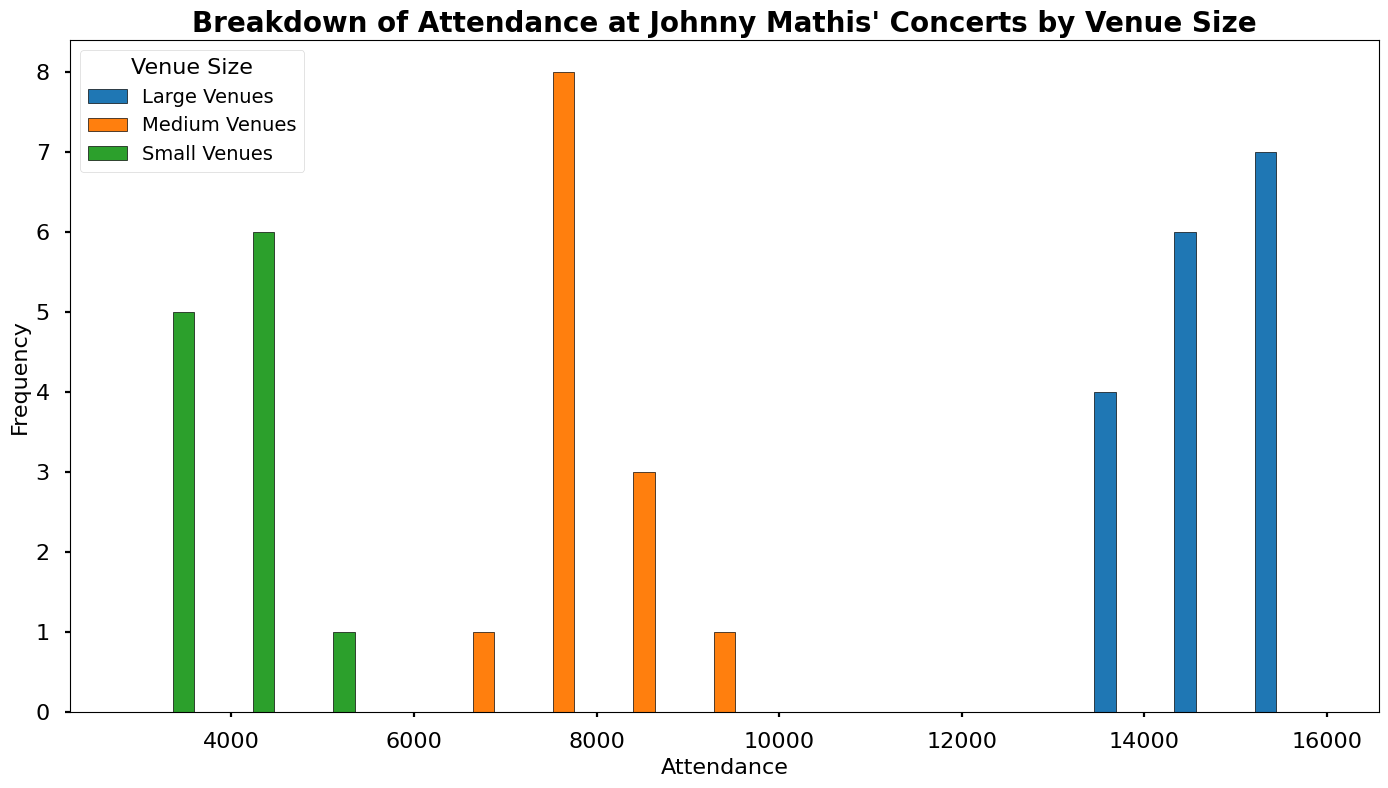What's the most frequent attendance range for Johnny Mathis' large venue concerts? Most of the large venue concerts fall in a similar attendance range. By observing the histogram for the blue bars (large venues), the most common attendance values are between 14,000 and 16,000.
Answer: 14,000-16,000 Between small, medium, and large venues, which one has the most consistent attendance? Consistency here would mean less variation in attendance numbers. Looking at the histograms, the large venue concerts (blue bars) seem to have attendance clustered within a narrower range compared to medium (orange bars) and small (green bars) venues.
Answer: Large venues Which venue size has the least frequent attendance of around 10,000? By looking at the histogram, there's hardly any attendance of around 10,000 in small venues (green bars) and medium venues (orange bars).
Answer: Small and Medium venues How does the attendance of medium-sized venues compare to small venues overall? By comparing the orange bars for medium-sized venues and green bars for small venues, medium-sized venues typically have higher attendance numbers compared to small venues overall.
Answer: Medium venues have higher attendance What's the difference in the highest attendance between large and medium venues? The highest attendance for large venues (blue bars) is around 16,000, whereas for medium-sized venues (orange bars), it is around 9,000. So the difference is 16,000 - 9,000.
Answer: 7,000 Which venue size has the widest range of attendance values? To determine the range, look at the spread of the histogram bars. The small venues (green bars) show the widest range, spanning from around 2,800 to 5,000.
Answer: Small venues Are there any overlaps in attendance numbers between medium and large venues? Yes, if you look closely, there's an overlap in attendance numbers between medium and large venues in the range of approximately 7,000 to 9,000.
Answer: Yes 